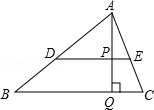Please explain what geometric properties this configuration might demonstrate. This diagram can demonstrate several geometric properties such as the properties of parallel lines, the concept of similar triangles, and the right angle properties in triangle APQ. The configuration also allows for exploration of ratios of segments split by a transversal line. 